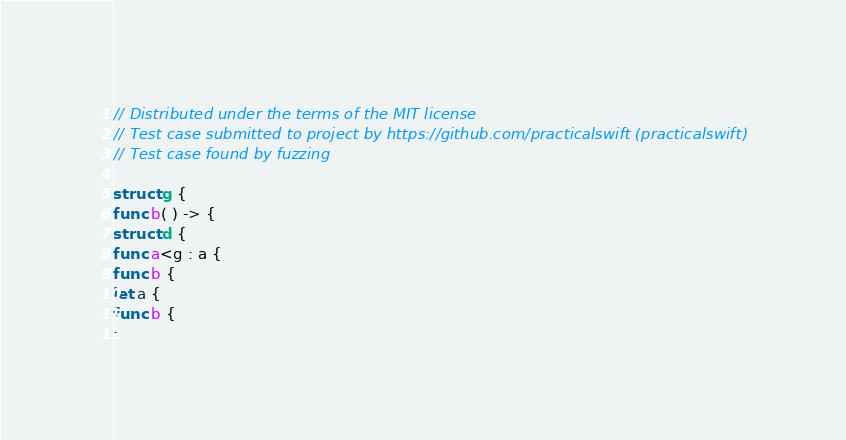Convert code to text. <code><loc_0><loc_0><loc_500><loc_500><_Swift_>// Distributed under the terms of the MIT license
// Test case submitted to project by https://github.com/practicalswift (practicalswift)
// Test case found by fuzzing

struct g {
func b( ) -> {
struct d {
func a<g : a {
func b {
let a {
func b {
:
</code> 